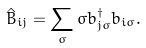Convert formula to latex. <formula><loc_0><loc_0><loc_500><loc_500>\hat { B } _ { i j } = \sum _ { \sigma } \sigma { b } ^ { \dagger } _ { j \sigma } { b } _ { i \sigma } .</formula> 